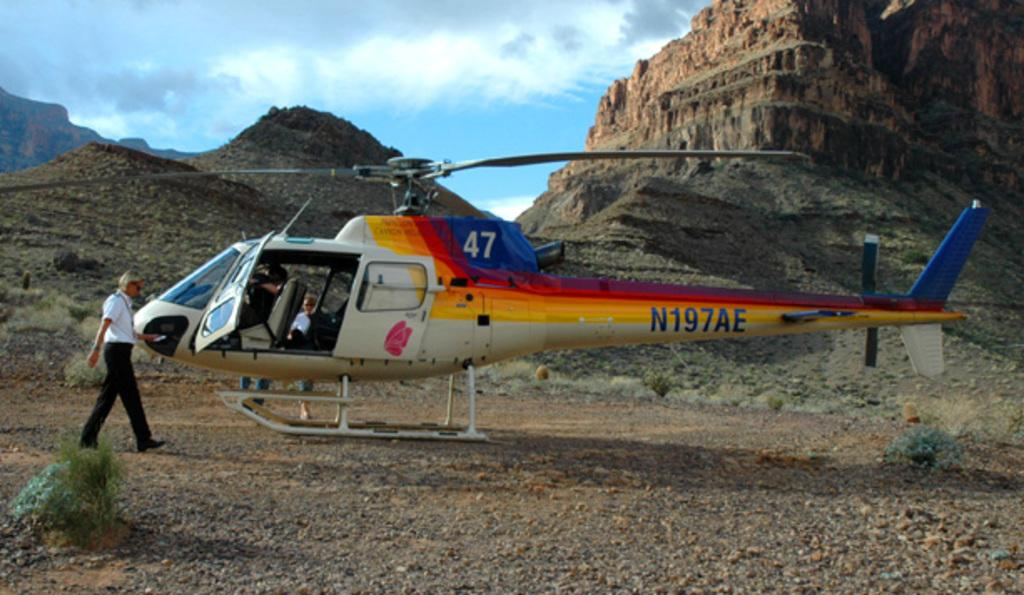<image>
Present a compact description of the photo's key features. the helicopter sitting at the bottom of the mountain says 47 